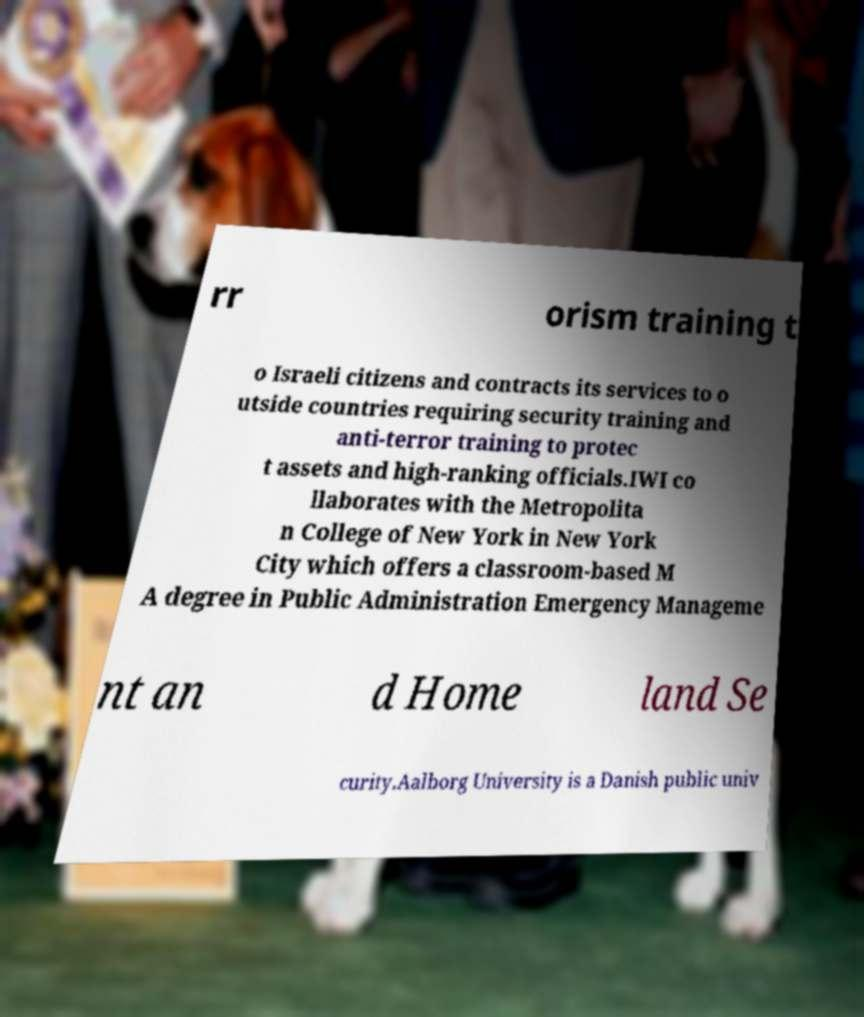There's text embedded in this image that I need extracted. Can you transcribe it verbatim? rr orism training t o Israeli citizens and contracts its services to o utside countries requiring security training and anti-terror training to protec t assets and high-ranking officials.IWI co llaborates with the Metropolita n College of New York in New York City which offers a classroom-based M A degree in Public Administration Emergency Manageme nt an d Home land Se curity.Aalborg University is a Danish public univ 